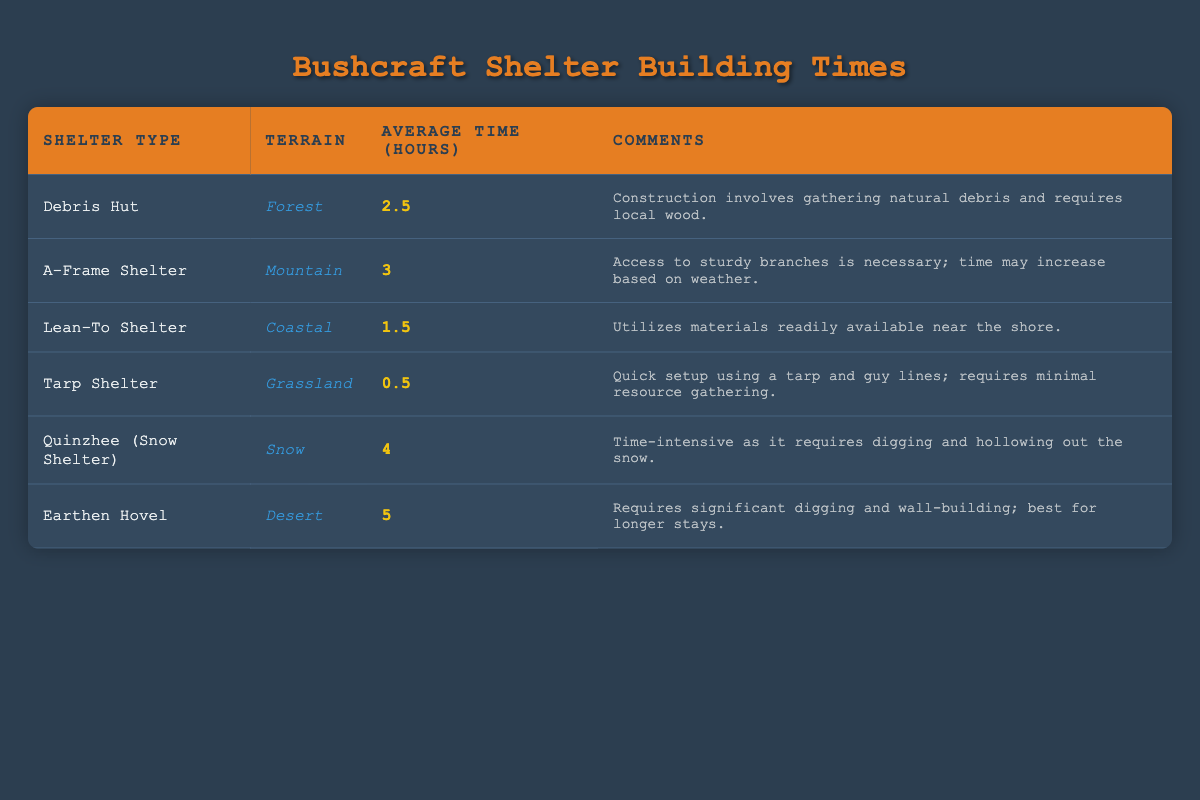What is the average time taken to build a Tarp Shelter? The table shows that the average time to build a Tarp Shelter is listed directly; it states 0.5 hours.
Answer: 0.5 hours Which shelter takes the longest time to build? From the table, we see that the Earthen Hovel has the longest average time to construct, recorded at 5 hours.
Answer: Earthen Hovel Is the average time to build a Lean-To Shelter less than 3 hours? The average time for a Lean-To Shelter is 1.5 hours, which is indeed less than 3 hours. Hence, the statement is true.
Answer: Yes What is the average time taken to build all the shelters? To find the average time, sum the times (2.5 + 3 + 1.5 + 0.5 + 4 + 5 = 17.5 hours) and divide by the number of shelters (6): 17.5/6 = 2.917 hours.
Answer: 2.917 hours Are there any shelters that take less than 2 hours to build? The table lists the Tarp Shelter, which takes 0.5 hours, and the Lean-To Shelter, which takes 1.5 hours. Both are less than 2 hours, making the statement true.
Answer: Yes Which terrains have shelters that require more than 3 hours of construction time? The table shows that the A-Frame Shelter (3 hours), Quinzhee (4 hours), and Earthen Hovel (5 hours) are the relevant entries. Both Quinzhee and Earthen Hovel meet the condition, while A-Frame only meets it if considered 3 hours or more, thus two distinct terrains (Mountain and Snow) can be named.
Answer: Mountain, Snow What is the difference in average time between the fastest and slowest shelter? The fastest is the Tarp Shelter (0.5 hours) and the slowest is the Earthen Hovel (5 hours). The difference is calculated as 5 - 0.5 = 4.5 hours.
Answer: 4.5 hours Is a Quinzhee preferred in snowy conditions compared to other shelters? The table indicates that the Quinzhee is specifically designed for snow terrain, making it preferable there compared to other shelters designed for different terrains.
Answer: Yes 